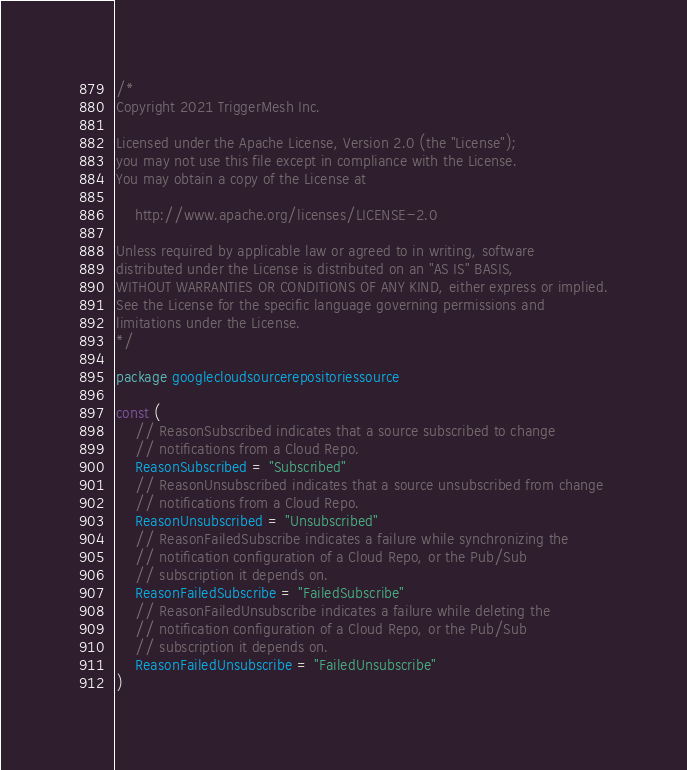<code> <loc_0><loc_0><loc_500><loc_500><_Go_>/*
Copyright 2021 TriggerMesh Inc.

Licensed under the Apache License, Version 2.0 (the "License");
you may not use this file except in compliance with the License.
You may obtain a copy of the License at

    http://www.apache.org/licenses/LICENSE-2.0

Unless required by applicable law or agreed to in writing, software
distributed under the License is distributed on an "AS IS" BASIS,
WITHOUT WARRANTIES OR CONDITIONS OF ANY KIND, either express or implied.
See the License for the specific language governing permissions and
limitations under the License.
*/

package googlecloudsourcerepositoriessource

const (
	// ReasonSubscribed indicates that a source subscribed to change
	// notifications from a Cloud Repo.
	ReasonSubscribed = "Subscribed"
	// ReasonUnsubscribed indicates that a source unsubscribed from change
	// notifications from a Cloud Repo.
	ReasonUnsubscribed = "Unsubscribed"
	// ReasonFailedSubscribe indicates a failure while synchronizing the
	// notification configuration of a Cloud Repo, or the Pub/Sub
	// subscription it depends on.
	ReasonFailedSubscribe = "FailedSubscribe"
	// ReasonFailedUnsubscribe indicates a failure while deleting the
	// notification configuration of a Cloud Repo, or the Pub/Sub
	// subscription it depends on.
	ReasonFailedUnsubscribe = "FailedUnsubscribe"
)
</code> 